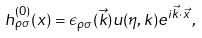<formula> <loc_0><loc_0><loc_500><loc_500>h ^ { ( 0 ) } _ { \rho \sigma } ( x ) = \epsilon _ { \rho \sigma } ( \vec { k } ) u ( \eta , k ) e ^ { i \vec { k } \cdot \vec { x } } \, ,</formula> 